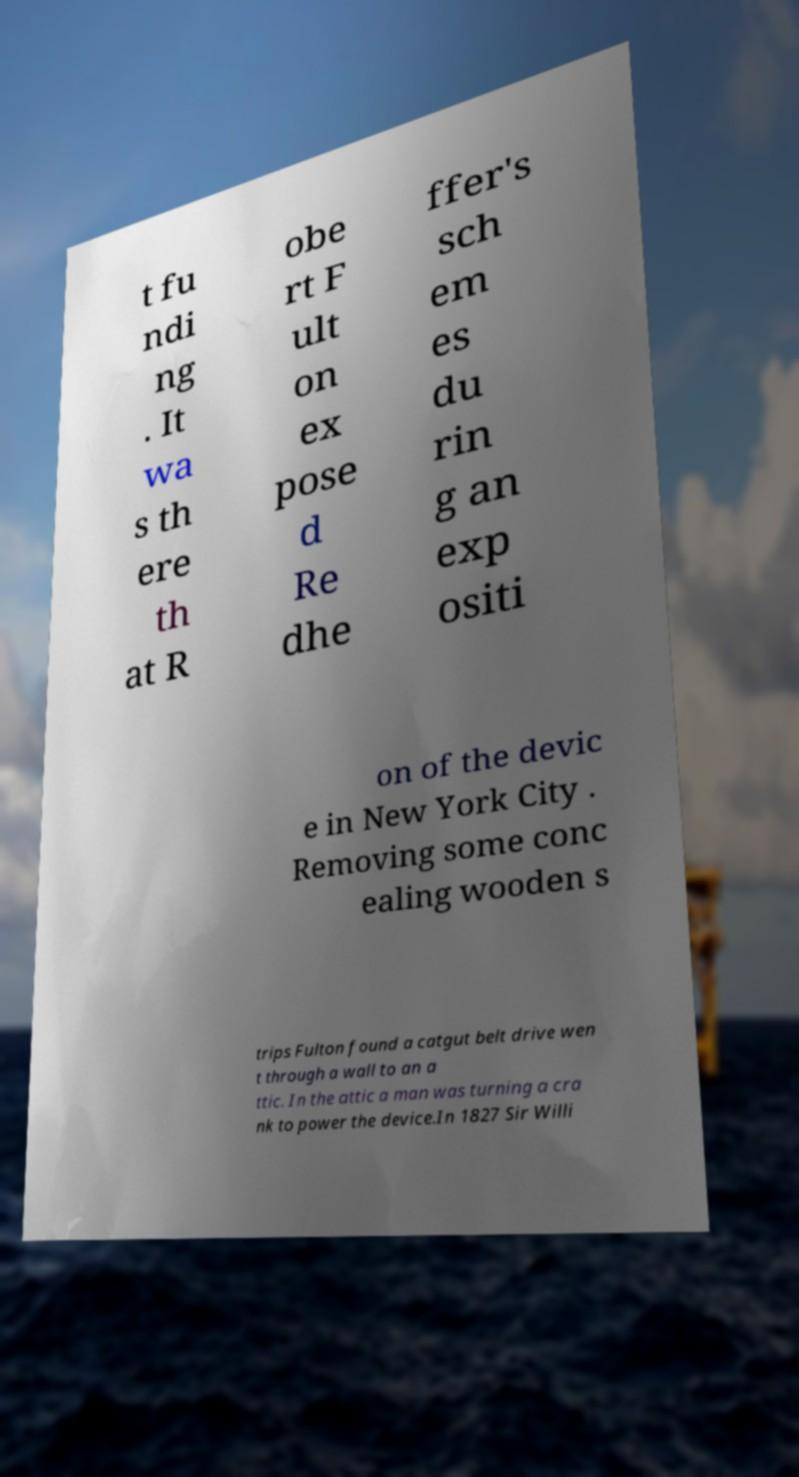For documentation purposes, I need the text within this image transcribed. Could you provide that? t fu ndi ng . It wa s th ere th at R obe rt F ult on ex pose d Re dhe ffer's sch em es du rin g an exp ositi on of the devic e in New York City . Removing some conc ealing wooden s trips Fulton found a catgut belt drive wen t through a wall to an a ttic. In the attic a man was turning a cra nk to power the device.In 1827 Sir Willi 